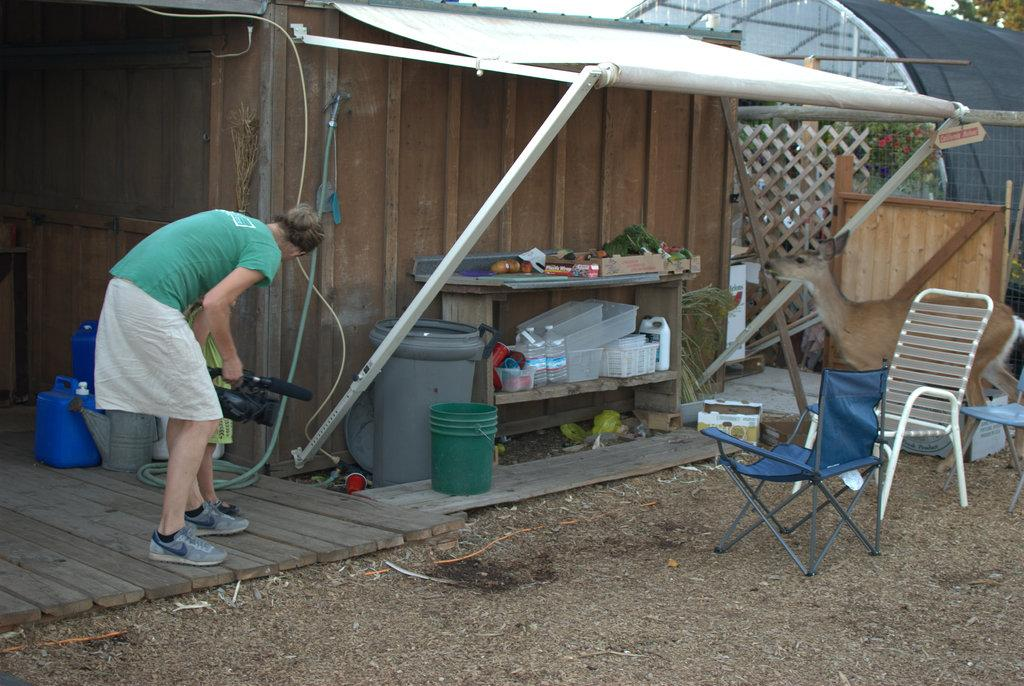What is the man in the image doing? The man is standing in the image and holding a camera. What objects can be seen in the background of the image? There are two chairs and a wall visible in the background of the image. What is on the table in the image? There are blocks on a table in the image. What type of structure is present in the image? There is a shed in the image. What type of poison is the man using to take pictures in the image? There is no poison present in the image, and the man is not using any poison to take pictures. 